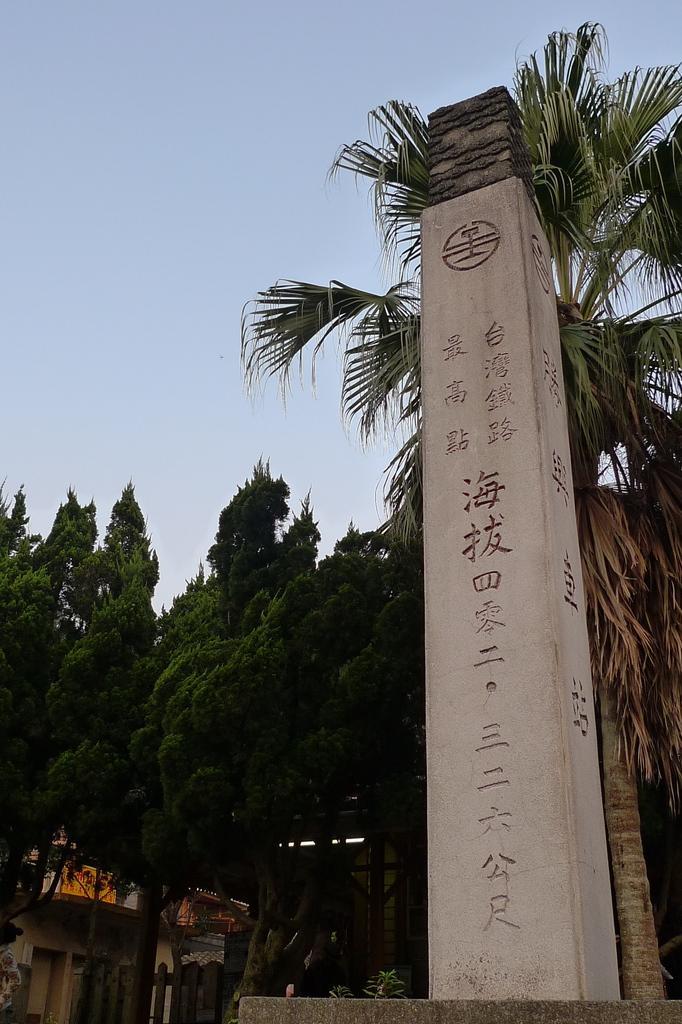Can you describe this image briefly? In this image, I can see buildings, trees, pillar, fence and the sky. This image taken, maybe during a day. 